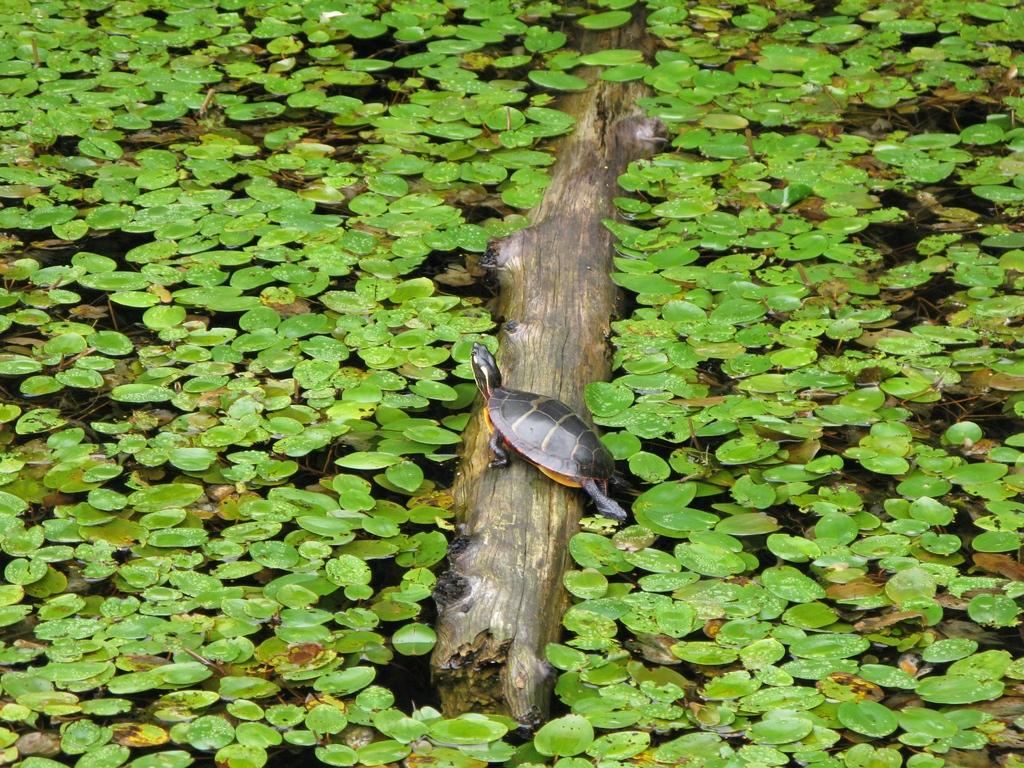What animal can be seen in the image? There is a tortoise in the image. Where is the tortoise located? The tortoise is on a stem in the image. What can be seen in the background of the image? There is water visible in the image. What type of vegetation is present in the water? There are plants in the water. What type of tub is visible in the image? There is no tub present in the image. 